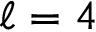Convert formula to latex. <formula><loc_0><loc_0><loc_500><loc_500>\ell = 4</formula> 